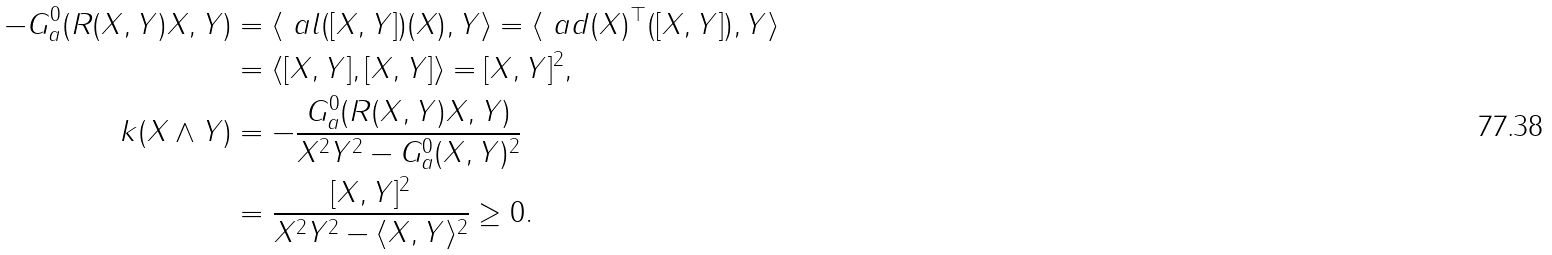Convert formula to latex. <formula><loc_0><loc_0><loc_500><loc_500>- G ^ { 0 } _ { a } ( R ( X , Y ) X , Y ) & = \langle \ a l ( [ X , Y ] ) ( X ) , Y \rangle = \langle \ a d ( X ) ^ { \top } ( [ X , Y ] ) , Y \rangle \\ & = \langle [ X , Y ] , [ X , Y ] \rangle = \| [ X , Y ] \| ^ { 2 } , \\ k ( X \wedge Y ) & = - \frac { G ^ { 0 } _ { a } ( R ( X , Y ) X , Y ) } { \| X \| ^ { 2 } \| Y \| ^ { 2 } - G ^ { 0 } _ { a } ( X , Y ) ^ { 2 } } \\ & = \frac { \| [ X , Y ] \| ^ { 2 } } { \| X \| ^ { 2 } \| Y \| ^ { 2 } - \langle X , Y \rangle ^ { 2 } } \geq 0 .</formula> 